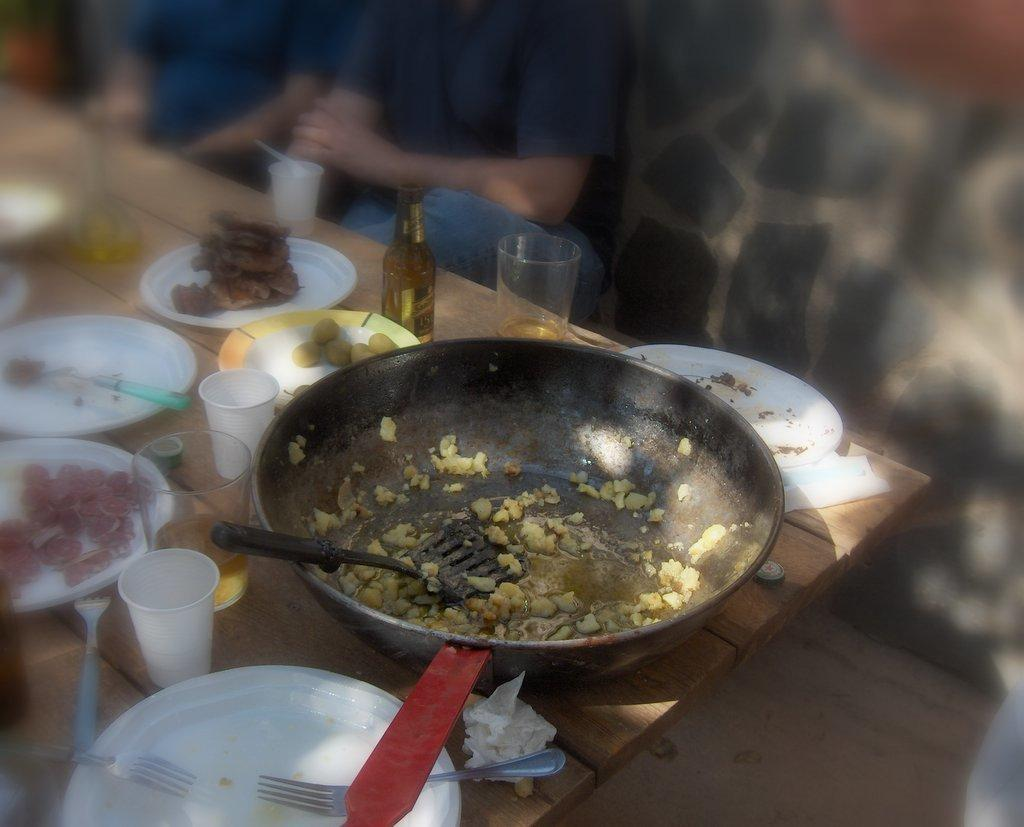What piece of furniture is in the image? There is a table in the image. What items are on the table? Plates, glasses, spoons, forks, tissue paper, and a water bottle are on the table. What objects might be used for eating or drinking? Spoons, forks, glasses, and plates might be used for eating or drinking. Are there any people in the image? Yes, there are people sitting on chairs in the image. What type of arch can be seen in the wilderness in the image? There is no arch or wilderness present in the image; it features a table with various items and people sitting on chairs. 